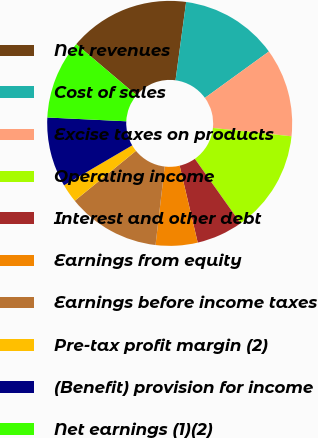<chart> <loc_0><loc_0><loc_500><loc_500><pie_chart><fcel>Net revenues<fcel>Cost of sales<fcel>Excise taxes on products<fcel>Operating income<fcel>Interest and other debt<fcel>Earnings from equity<fcel>Earnings before income taxes<fcel>Pre-tax profit margin (2)<fcel>(Benefit) provision for income<fcel>Net earnings (1)(2)<nl><fcel>15.95%<fcel>12.88%<fcel>11.66%<fcel>13.5%<fcel>6.14%<fcel>5.52%<fcel>12.27%<fcel>2.45%<fcel>9.2%<fcel>10.43%<nl></chart> 